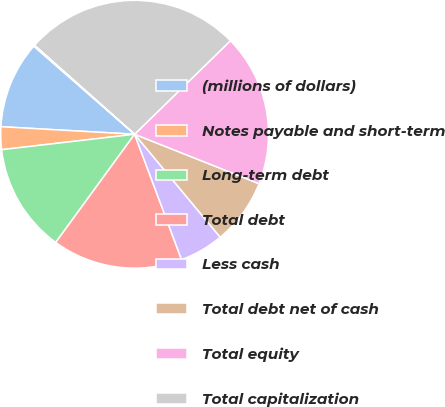Convert chart to OTSL. <chart><loc_0><loc_0><loc_500><loc_500><pie_chart><fcel>(millions of dollars)<fcel>Notes payable and short-term<fcel>Long-term debt<fcel>Total debt<fcel>Less cash<fcel>Total debt net of cash<fcel>Total equity<fcel>Total capitalization<fcel>Total debt net of cash to<nl><fcel>10.53%<fcel>2.74%<fcel>13.13%<fcel>15.73%<fcel>5.34%<fcel>7.94%<fcel>18.33%<fcel>26.12%<fcel>0.14%<nl></chart> 